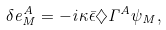<formula> <loc_0><loc_0><loc_500><loc_500>\delta e ^ { A } _ { M } = - i \kappa { \bar { \epsilon } } \diamondsuit \Gamma ^ { A } \psi _ { M } ,</formula> 